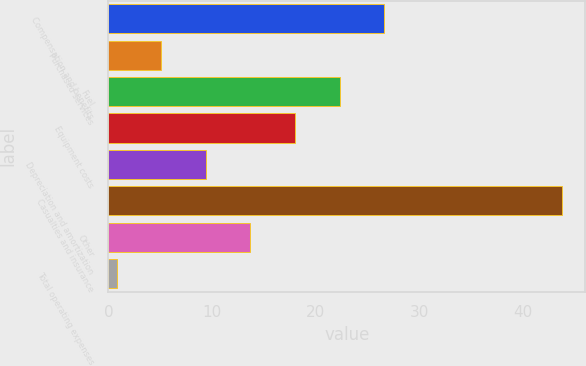Convert chart to OTSL. <chart><loc_0><loc_0><loc_500><loc_500><bar_chart><fcel>Compensation and benefits<fcel>Purchased services<fcel>Fuel<fcel>Equipment costs<fcel>Depreciation and amortization<fcel>Casualties and insurance<fcel>Other<fcel>Total operating expenses<nl><fcel>26.6<fcel>5.1<fcel>22.3<fcel>18<fcel>9.4<fcel>43.8<fcel>13.7<fcel>0.8<nl></chart> 